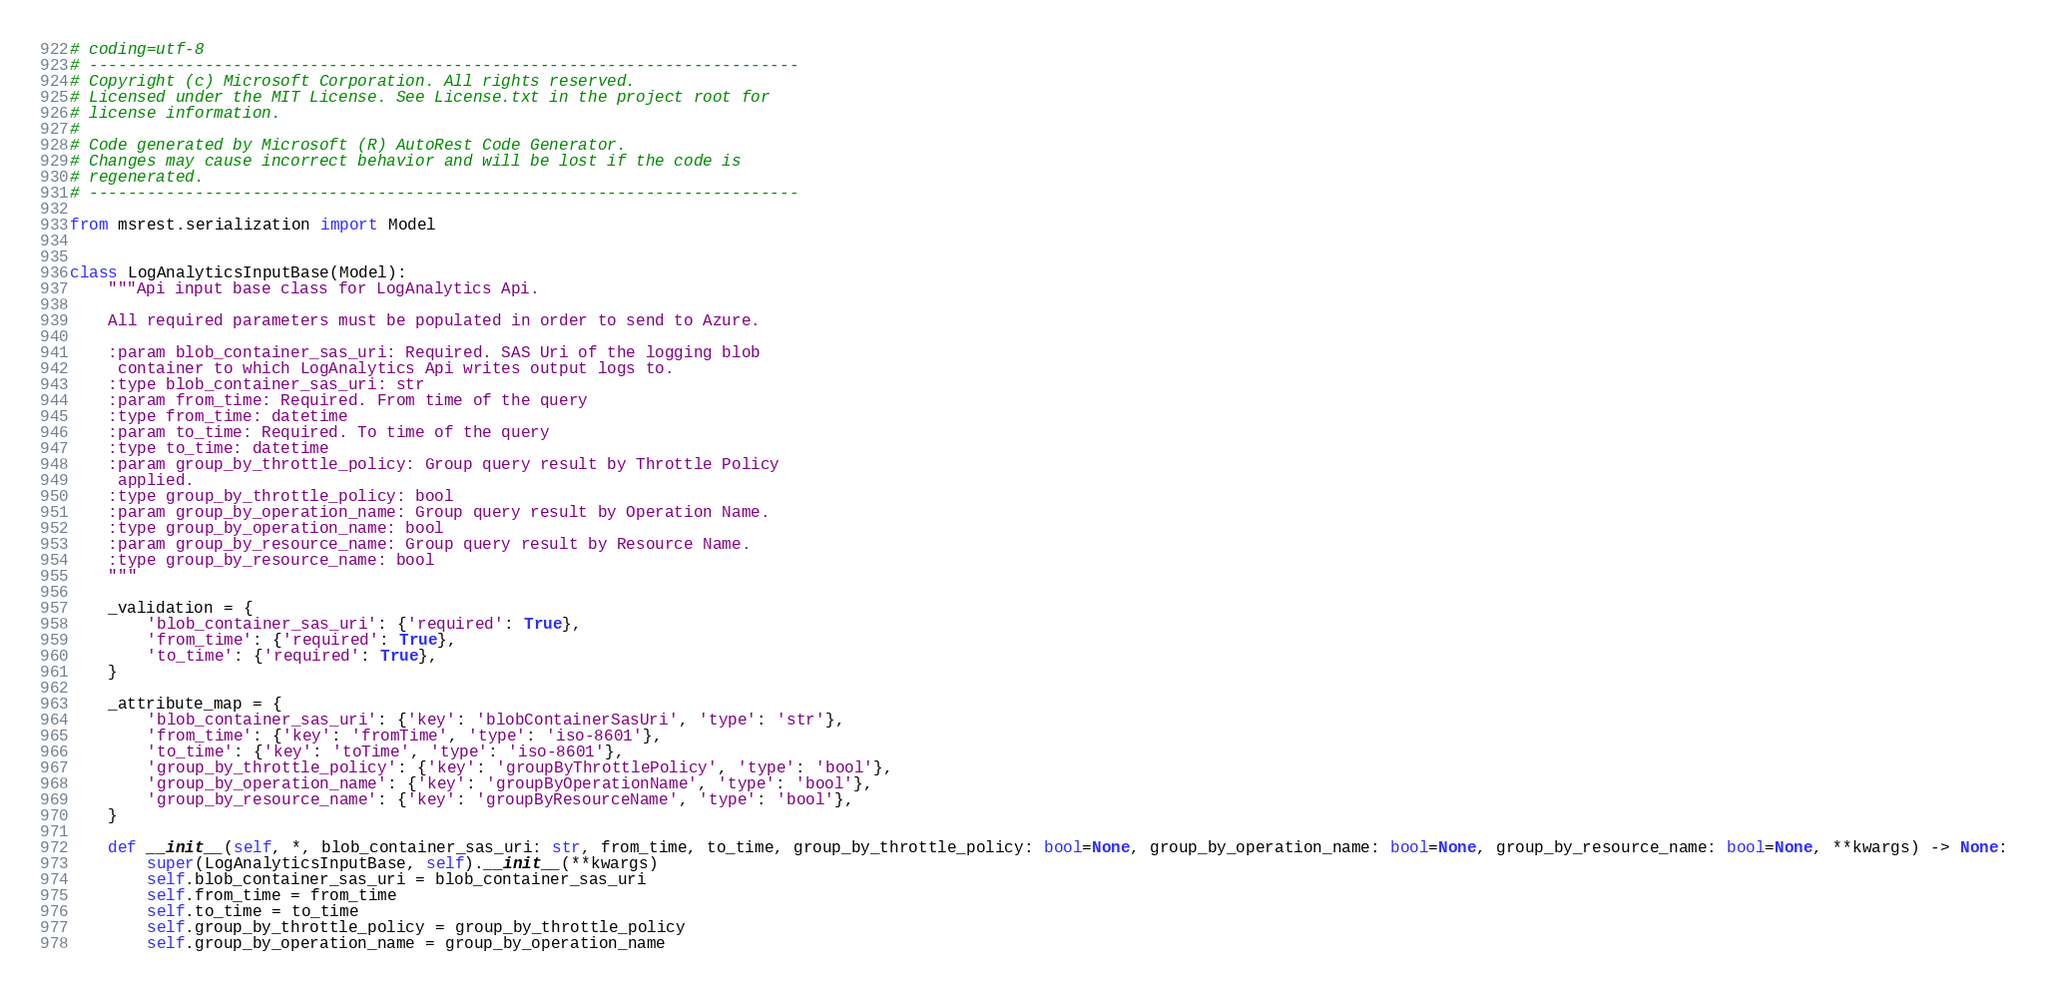Convert code to text. <code><loc_0><loc_0><loc_500><loc_500><_Python_># coding=utf-8
# --------------------------------------------------------------------------
# Copyright (c) Microsoft Corporation. All rights reserved.
# Licensed under the MIT License. See License.txt in the project root for
# license information.
#
# Code generated by Microsoft (R) AutoRest Code Generator.
# Changes may cause incorrect behavior and will be lost if the code is
# regenerated.
# --------------------------------------------------------------------------

from msrest.serialization import Model


class LogAnalyticsInputBase(Model):
    """Api input base class for LogAnalytics Api.

    All required parameters must be populated in order to send to Azure.

    :param blob_container_sas_uri: Required. SAS Uri of the logging blob
     container to which LogAnalytics Api writes output logs to.
    :type blob_container_sas_uri: str
    :param from_time: Required. From time of the query
    :type from_time: datetime
    :param to_time: Required. To time of the query
    :type to_time: datetime
    :param group_by_throttle_policy: Group query result by Throttle Policy
     applied.
    :type group_by_throttle_policy: bool
    :param group_by_operation_name: Group query result by Operation Name.
    :type group_by_operation_name: bool
    :param group_by_resource_name: Group query result by Resource Name.
    :type group_by_resource_name: bool
    """

    _validation = {
        'blob_container_sas_uri': {'required': True},
        'from_time': {'required': True},
        'to_time': {'required': True},
    }

    _attribute_map = {
        'blob_container_sas_uri': {'key': 'blobContainerSasUri', 'type': 'str'},
        'from_time': {'key': 'fromTime', 'type': 'iso-8601'},
        'to_time': {'key': 'toTime', 'type': 'iso-8601'},
        'group_by_throttle_policy': {'key': 'groupByThrottlePolicy', 'type': 'bool'},
        'group_by_operation_name': {'key': 'groupByOperationName', 'type': 'bool'},
        'group_by_resource_name': {'key': 'groupByResourceName', 'type': 'bool'},
    }

    def __init__(self, *, blob_container_sas_uri: str, from_time, to_time, group_by_throttle_policy: bool=None, group_by_operation_name: bool=None, group_by_resource_name: bool=None, **kwargs) -> None:
        super(LogAnalyticsInputBase, self).__init__(**kwargs)
        self.blob_container_sas_uri = blob_container_sas_uri
        self.from_time = from_time
        self.to_time = to_time
        self.group_by_throttle_policy = group_by_throttle_policy
        self.group_by_operation_name = group_by_operation_name</code> 